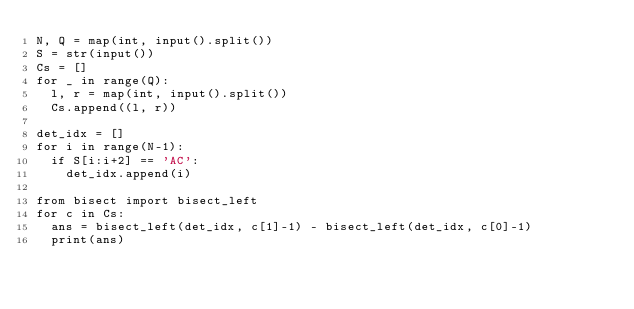Convert code to text. <code><loc_0><loc_0><loc_500><loc_500><_Python_>N, Q = map(int, input().split())
S = str(input())
Cs = []
for _ in range(Q):
  l, r = map(int, input().split())
  Cs.append((l, r))

det_idx = []
for i in range(N-1):
  if S[i:i+2] == 'AC':
    det_idx.append(i)

from bisect import bisect_left
for c in Cs:
  ans = bisect_left(det_idx, c[1]-1) - bisect_left(det_idx, c[0]-1)
  print(ans)</code> 